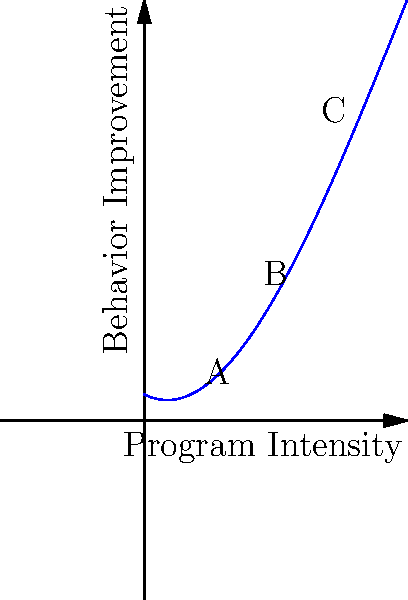The polynomial function represented by the curve above models the impact of rehabilitation program intensity on criminal behavior improvement. Considering the shape of the curve and your experience with the Scottish Sentencing Council, at which point (A, B, or C) would you recommend operating the rehabilitation program for optimal effectiveness, and why? To determine the optimal point for operating the rehabilitation program, we need to analyze the curve:

1. Point A (low intensity): 
   - Shows some improvement but not optimal
   - May represent minimal intervention

2. Point B (medium intensity):
   - Located near the peak of the curve
   - Represents the highest point of behavior improvement
   - Optimal balance between program intensity and results

3. Point C (high intensity):
   - Shows a decline in effectiveness
   - Represents diminishing returns or potential negative impacts

Step-by-step analysis:
1. The curve is a cubic function, starting low, rising to a peak, then declining.
2. It represents the relationship between program intensity (x-axis) and behavior improvement (y-axis).
3. The shape suggests there's an optimal point where increased intensity no longer yields proportional benefits.
4. Point B is closest to this optimal point, maximizing improvement while minimizing resource expenditure.
5. Beyond point B, increased intensity yields diminishing returns and potentially negative outcomes.

From a judicial and policy perspective, operating at point B would be most effective:
- It maximizes the positive impact on behavior.
- It uses resources efficiently.
- It avoids potential negative effects of over-intensive programs.

This aligns with evidence-based practices in criminal rehabilitation and the principles of proportionate sentencing.
Answer: Point B, as it represents the optimal balance between program intensity and behavior improvement, maximizing effectiveness while avoiding diminishing returns. 